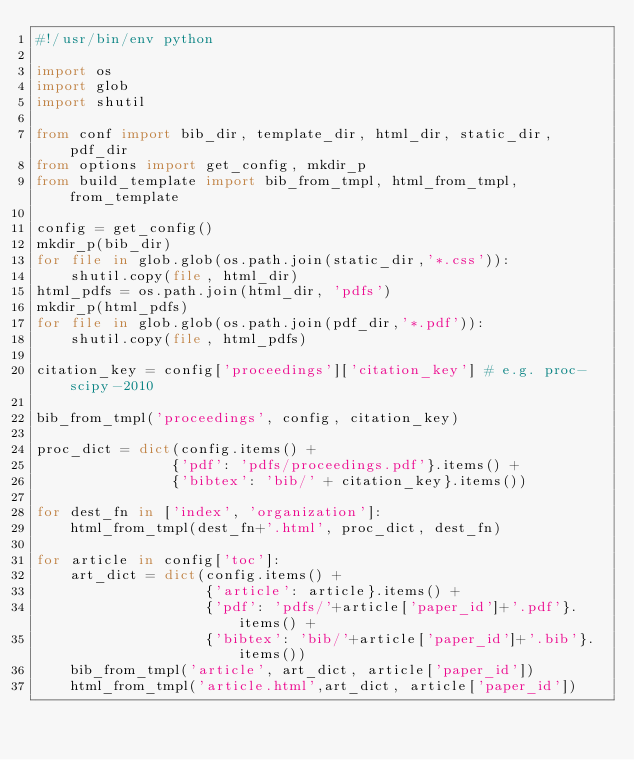<code> <loc_0><loc_0><loc_500><loc_500><_Python_>#!/usr/bin/env python

import os
import glob
import shutil

from conf import bib_dir, template_dir, html_dir, static_dir, pdf_dir
from options import get_config, mkdir_p
from build_template import bib_from_tmpl, html_from_tmpl, from_template

config = get_config()
mkdir_p(bib_dir)
for file in glob.glob(os.path.join(static_dir,'*.css')):
    shutil.copy(file, html_dir)
html_pdfs = os.path.join(html_dir, 'pdfs')
mkdir_p(html_pdfs)
for file in glob.glob(os.path.join(pdf_dir,'*.pdf')):
    shutil.copy(file, html_pdfs)

citation_key = config['proceedings']['citation_key'] # e.g. proc-scipy-2010

bib_from_tmpl('proceedings', config, citation_key)

proc_dict = dict(config.items() +
                {'pdf': 'pdfs/proceedings.pdf'}.items() +
                {'bibtex': 'bib/' + citation_key}.items())

for dest_fn in ['index', 'organization']:
    html_from_tmpl(dest_fn+'.html', proc_dict, dest_fn)

for article in config['toc']:
    art_dict = dict(config.items() +
                    {'article': article}.items() +
                    {'pdf': 'pdfs/'+article['paper_id']+'.pdf'}.items() +
                    {'bibtex': 'bib/'+article['paper_id']+'.bib'}.items())
    bib_from_tmpl('article', art_dict, article['paper_id'])
    html_from_tmpl('article.html',art_dict, article['paper_id'])
</code> 